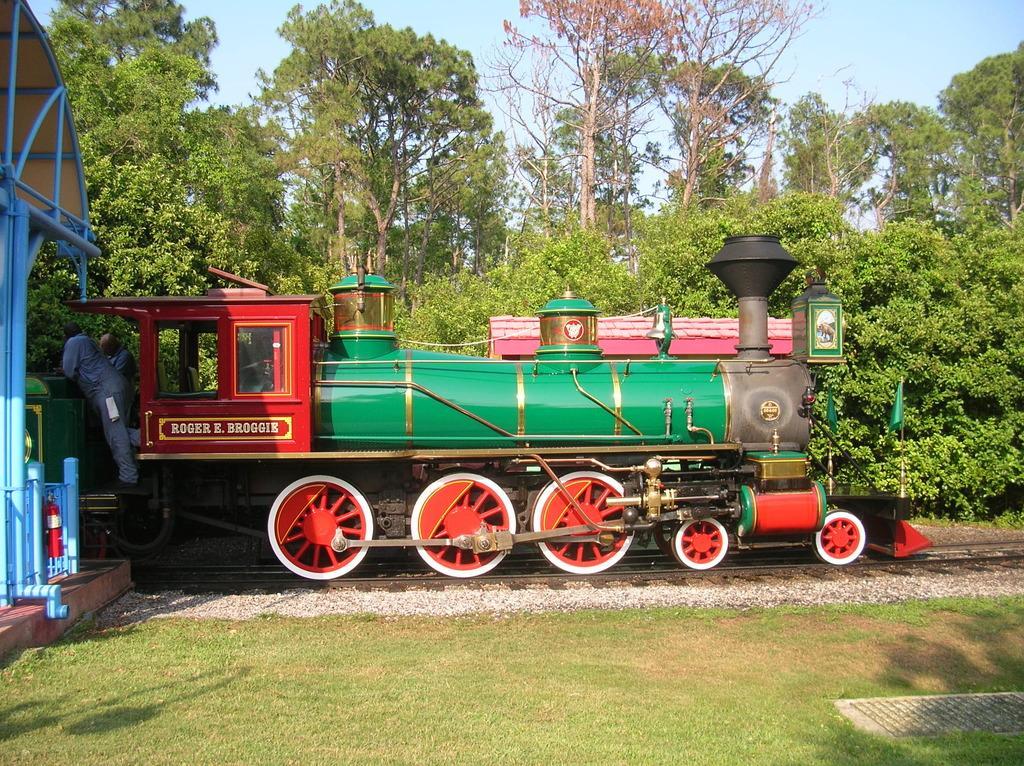Can you describe this image briefly? In this image, we can see a train on the railway track. We can see the ground with grass and some objects. There are a few trees, plants and people. We can also see the shed on the left. We can see the sky. We can also see some objects on the left. 